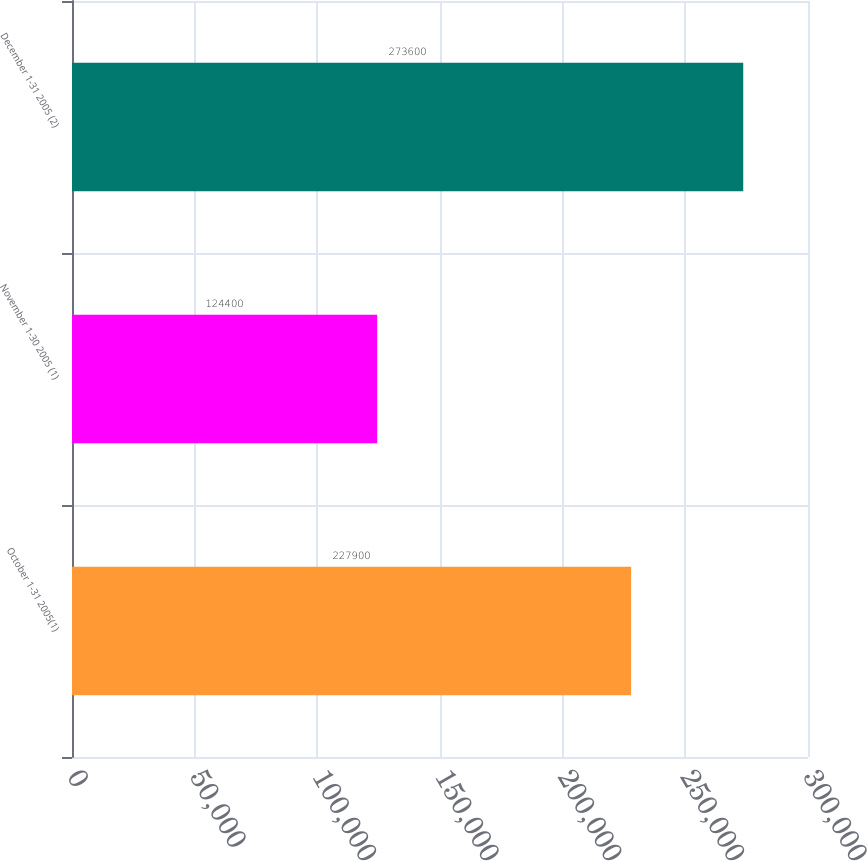Convert chart. <chart><loc_0><loc_0><loc_500><loc_500><bar_chart><fcel>October 1-31 2005(1)<fcel>November 1-30 2005 (1)<fcel>December 1-31 2005 (2)<nl><fcel>227900<fcel>124400<fcel>273600<nl></chart> 